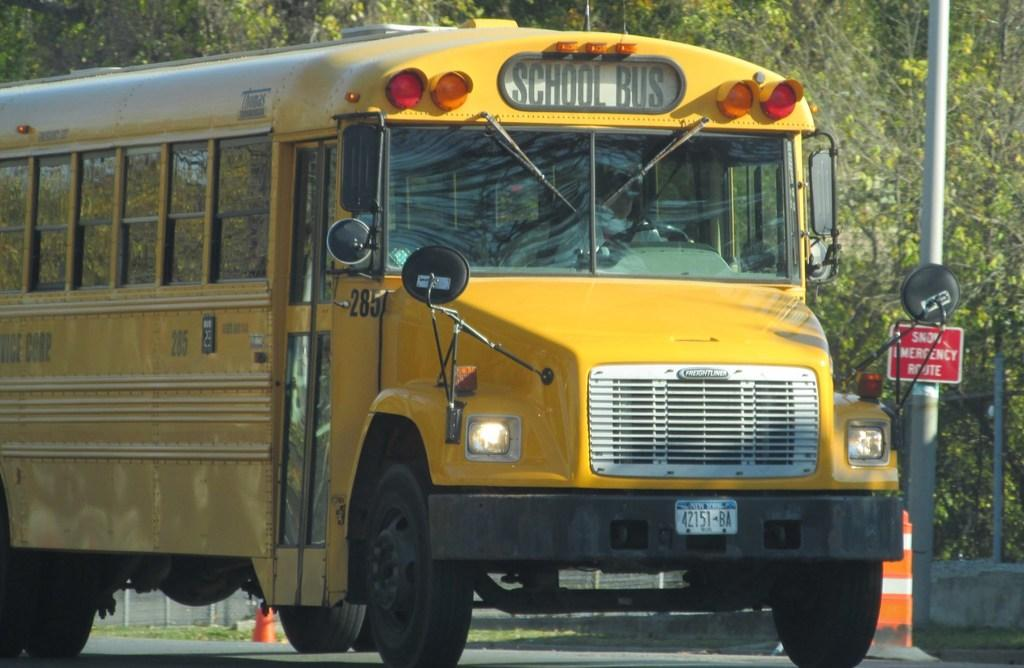<image>
Present a compact description of the photo's key features. the front end of a yellow School Bus 